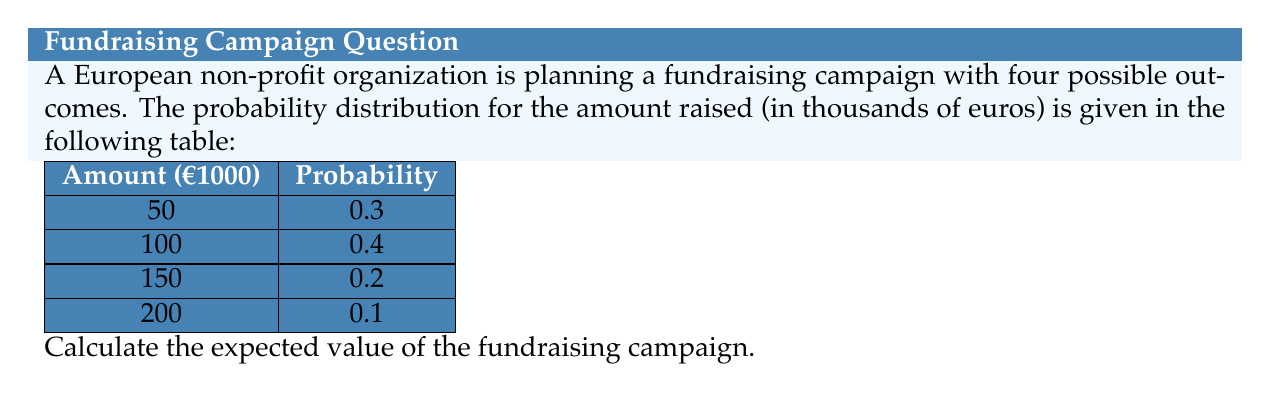Teach me how to tackle this problem. To calculate the expected value of a discrete probability distribution, we use the formula:

$$ E(X) = \sum_{i=1}^n x_i \cdot p(x_i) $$

Where $x_i$ are the possible values and $p(x_i)$ are their respective probabilities.

Step 1: Multiply each amount by its probability:
- 50 * 0.3 = 15
- 100 * 0.4 = 40
- 150 * 0.2 = 30
- 200 * 0.1 = 20

Step 2: Sum the products:

$$ E(X) = 15 + 40 + 30 + 20 = 105 $$

Therefore, the expected value of the fundraising campaign is €105,000.
Answer: €105,000 